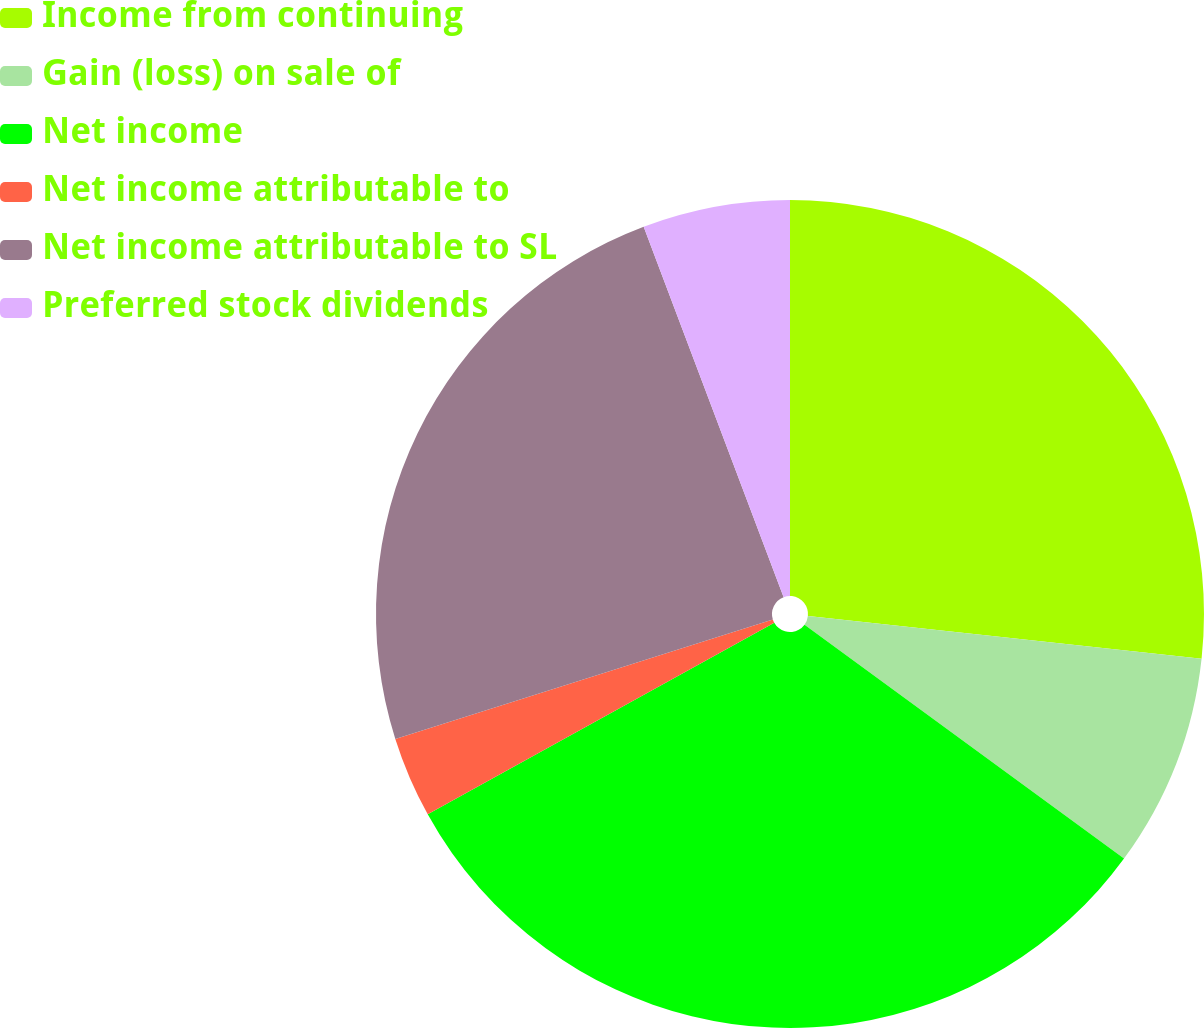Convert chart. <chart><loc_0><loc_0><loc_500><loc_500><pie_chart><fcel>Income from continuing<fcel>Gain (loss) on sale of<fcel>Net income<fcel>Net income attributable to<fcel>Net income attributable to SL<fcel>Preferred stock dividends<nl><fcel>26.72%<fcel>8.34%<fcel>31.9%<fcel>3.16%<fcel>24.13%<fcel>5.75%<nl></chart> 